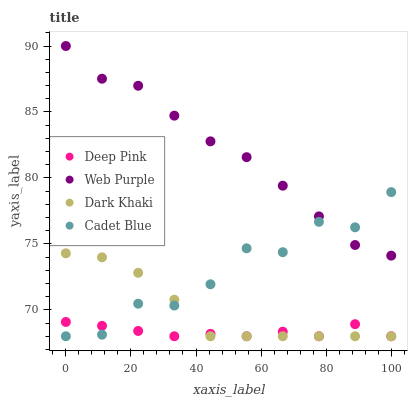Does Deep Pink have the minimum area under the curve?
Answer yes or no. Yes. Does Web Purple have the maximum area under the curve?
Answer yes or no. Yes. Does Web Purple have the minimum area under the curve?
Answer yes or no. No. Does Deep Pink have the maximum area under the curve?
Answer yes or no. No. Is Dark Khaki the smoothest?
Answer yes or no. Yes. Is Cadet Blue the roughest?
Answer yes or no. Yes. Is Web Purple the smoothest?
Answer yes or no. No. Is Web Purple the roughest?
Answer yes or no. No. Does Dark Khaki have the lowest value?
Answer yes or no. Yes. Does Web Purple have the lowest value?
Answer yes or no. No. Does Web Purple have the highest value?
Answer yes or no. Yes. Does Deep Pink have the highest value?
Answer yes or no. No. Is Dark Khaki less than Web Purple?
Answer yes or no. Yes. Is Web Purple greater than Dark Khaki?
Answer yes or no. Yes. Does Cadet Blue intersect Dark Khaki?
Answer yes or no. Yes. Is Cadet Blue less than Dark Khaki?
Answer yes or no. No. Is Cadet Blue greater than Dark Khaki?
Answer yes or no. No. Does Dark Khaki intersect Web Purple?
Answer yes or no. No. 